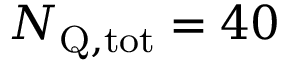Convert formula to latex. <formula><loc_0><loc_0><loc_500><loc_500>{ N _ { Q , t o t } } = 4 0</formula> 